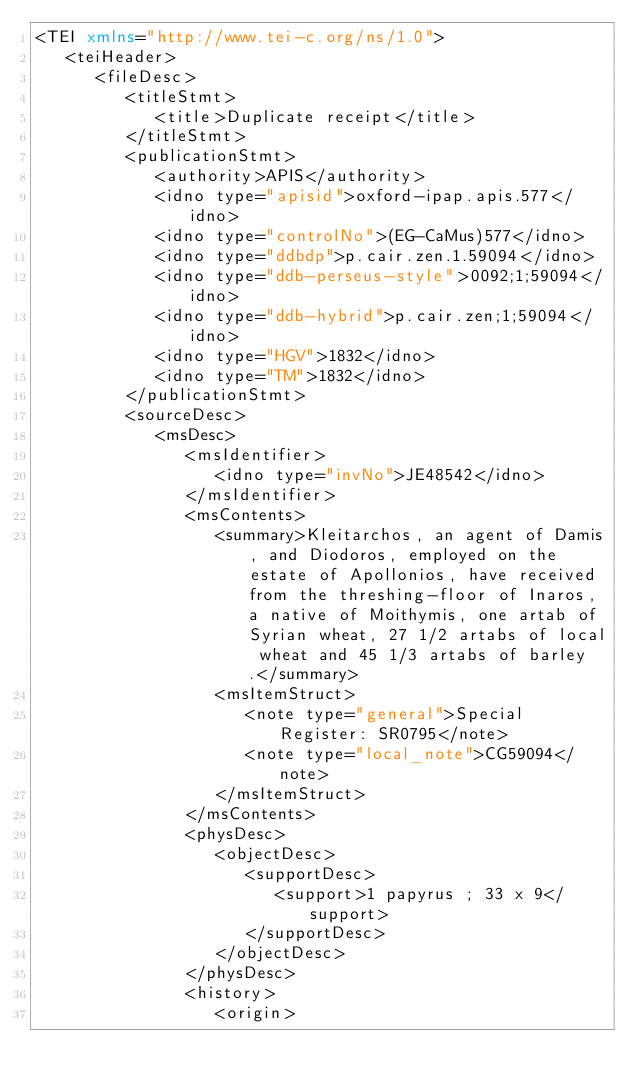<code> <loc_0><loc_0><loc_500><loc_500><_XML_><TEI xmlns="http://www.tei-c.org/ns/1.0">
   <teiHeader>
      <fileDesc>
         <titleStmt>
            <title>Duplicate receipt</title>
         </titleStmt>
         <publicationStmt>
            <authority>APIS</authority>
            <idno type="apisid">oxford-ipap.apis.577</idno>
            <idno type="controlNo">(EG-CaMus)577</idno>
            <idno type="ddbdp">p.cair.zen.1.59094</idno>
            <idno type="ddb-perseus-style">0092;1;59094</idno>
            <idno type="ddb-hybrid">p.cair.zen;1;59094</idno>
            <idno type="HGV">1832</idno>
            <idno type="TM">1832</idno>
         </publicationStmt>
         <sourceDesc>
            <msDesc>
               <msIdentifier>
                  <idno type="invNo">JE48542</idno>
               </msIdentifier>
               <msContents>
                  <summary>Kleitarchos, an agent of Damis, and Diodoros, employed on the estate of Apollonios, have received from the threshing-floor of Inaros, a native of Moithymis, one artab of Syrian wheat, 27 1/2 artabs of local wheat and 45 1/3 artabs of barley.</summary>
                  <msItemStruct>
                     <note type="general">Special Register: SR0795</note>
                     <note type="local_note">CG59094</note>
                  </msItemStruct>
               </msContents>
               <physDesc>
                  <objectDesc>
                     <supportDesc>
                        <support>1 papyrus ; 33 x 9</support>
                     </supportDesc>
                  </objectDesc>
               </physDesc>
               <history>
                  <origin></code> 